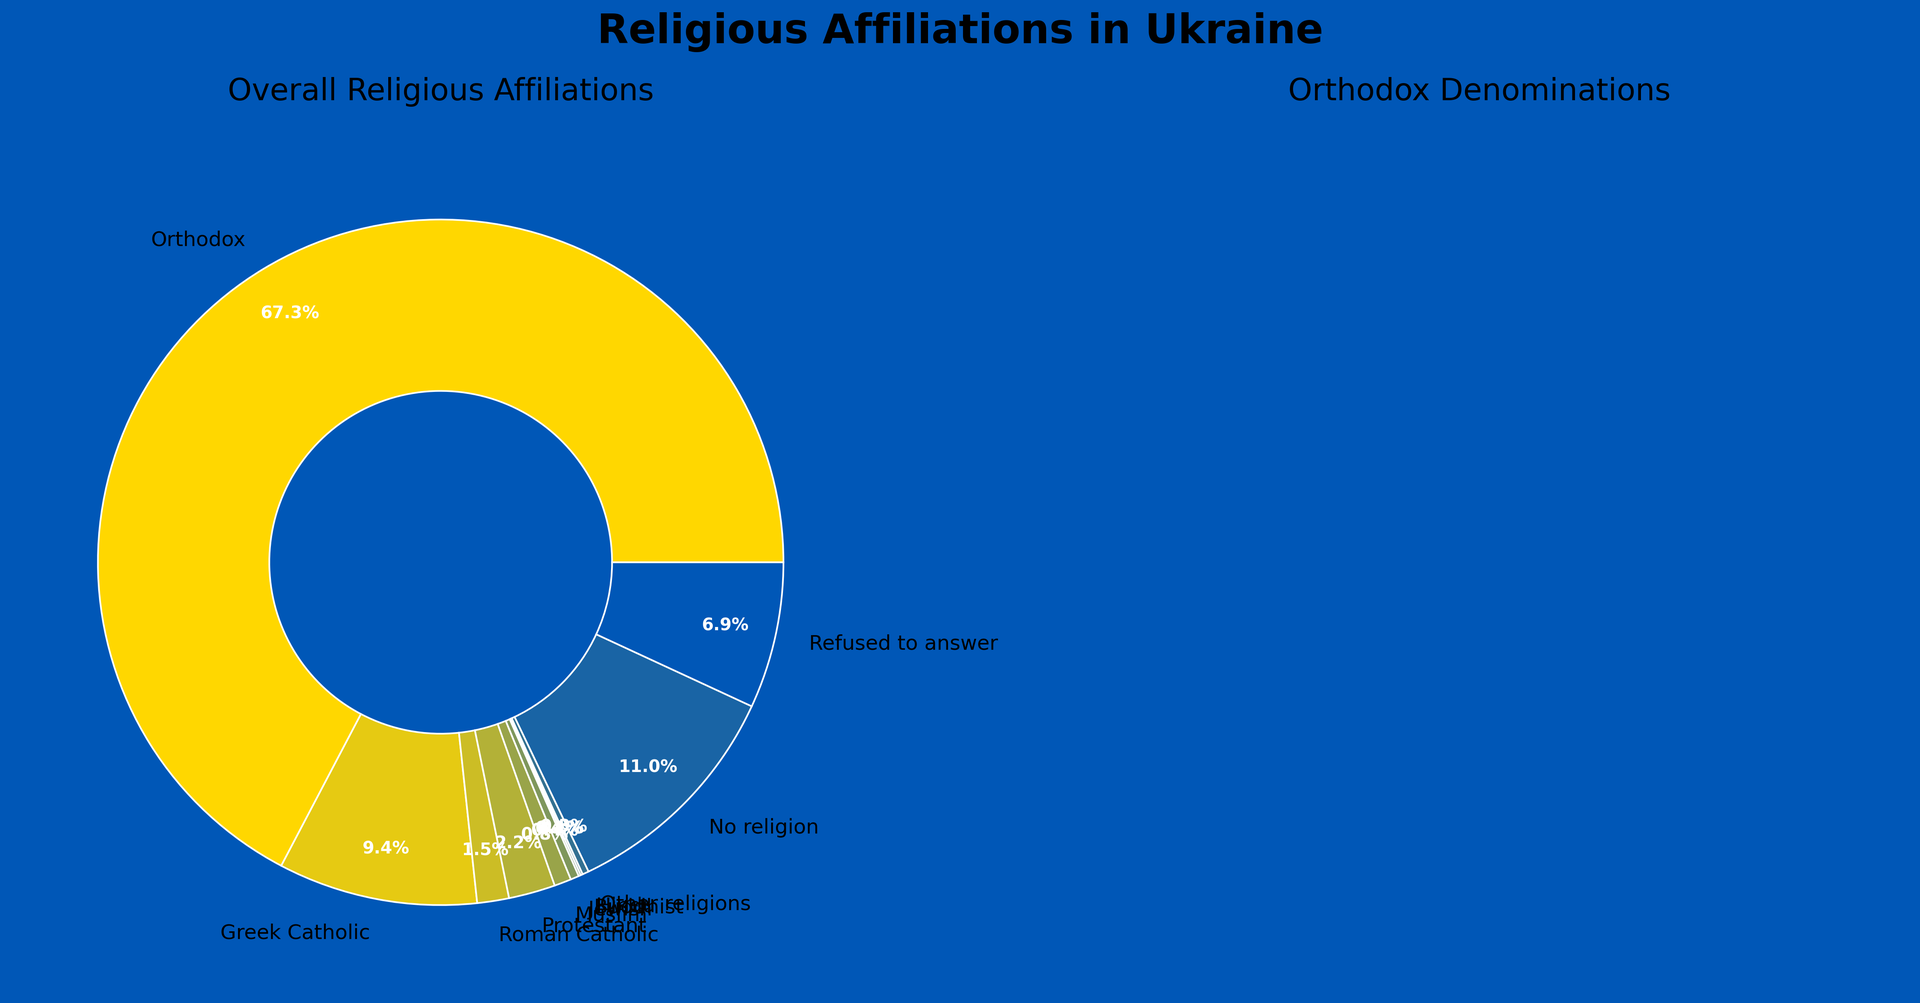What percentage of the Ukrainian population identifies as Greek Catholic? Referring to the primary pie chart for overall religious affiliations, we can see that Greek Catholic is labeled with a percentage of 9.4%.
Answer: 9.4% Which Orthodox denomination has the largest percentage and what is that percentage? From the Orthodox denominations pie chart, we see that the Ukrainian Orthodox Church (Moscow Patriarchate) has the largest percentage, labeled as 29.3%.
Answer: Ukrainian Orthodox Church (Moscow Patriarchate), 29.3% Calculate the total percentage of Ukrainian population that identifies with an Orthodox denomination other than the Ukrainian Orthodox Church (Moscow Patriarchate). According to the Orthodox denominations pie chart, sum the percentages of the Orthodox Church of Ukraine (28.7%), Ukrainian Autocephalous Orthodox Church (5.2%), and Other Orthodox (4.1%). 28.7 + 5.2 + 4.1 = 38.0%
Answer: 38.0% Compare the percentage of people who identify as Roman Catholic to those who identify as Protestant. Which is higher and by how much? The primary pie chart shows Roman Catholic at 1.5% and Protestant at 2.2%. The difference is 2.2 - 1.5 = 0.7%. Thus, Protestant is higher by 0.7%.
Answer: Protestant by 0.7% What color represents the background of the overall religious affiliations pie chart? Visually, the background of the overall religious affiliations pie chart is yellow, referencing the colors of the Ukrainian flag used.
Answer: Yellow What is the total percentage of the Ukrainian population that is either Muslim or Jewish? Referring to the primary pie chart, Muslim is 0.8% and Jewish is 0.4%. Adding them together, 0.8 + 0.4 = 1.2%.
Answer: 1.2% Identify the smallest religious group in Ukraine based on the primary pie chart. What percentage do they represent? According to the primary pie chart, the smallest group is tied between Buddhist and Hindu, each representing 0.1%.
Answer: Buddhist, Hindu, 0.1% How much greater is the percentage of people with no religion compared to those who refused to answer? From the primary pie chart, no religion is at 11.0% and refused to answer is at 6.9%. The difference is 11.0 - 6.9 = 4.1%.
Answer: 4.1% Based on the Orthodox denominations pie chart, what is the combined percentage of people identifying with the Ukrainian Orthodox Church (Moscow Patriarchate) and the Orthodox Church of Ukraine? Sum the percentages of the Ukrainian Orthodox Church (Moscow Patriarchate) at 29.3% and the Orthodox Church of Ukraine at 28.7%. 29.3 + 28.7 = 58.0%
Answer: 58.0% What is the second most prevalent Orthodox denomination in Ukraine? From the Orthodox denominations pie chart, the second most prevalent denomination is the Orthodox Church of Ukraine at 28.7%.
Answer: Orthodox Church of Ukraine, 28.7% 